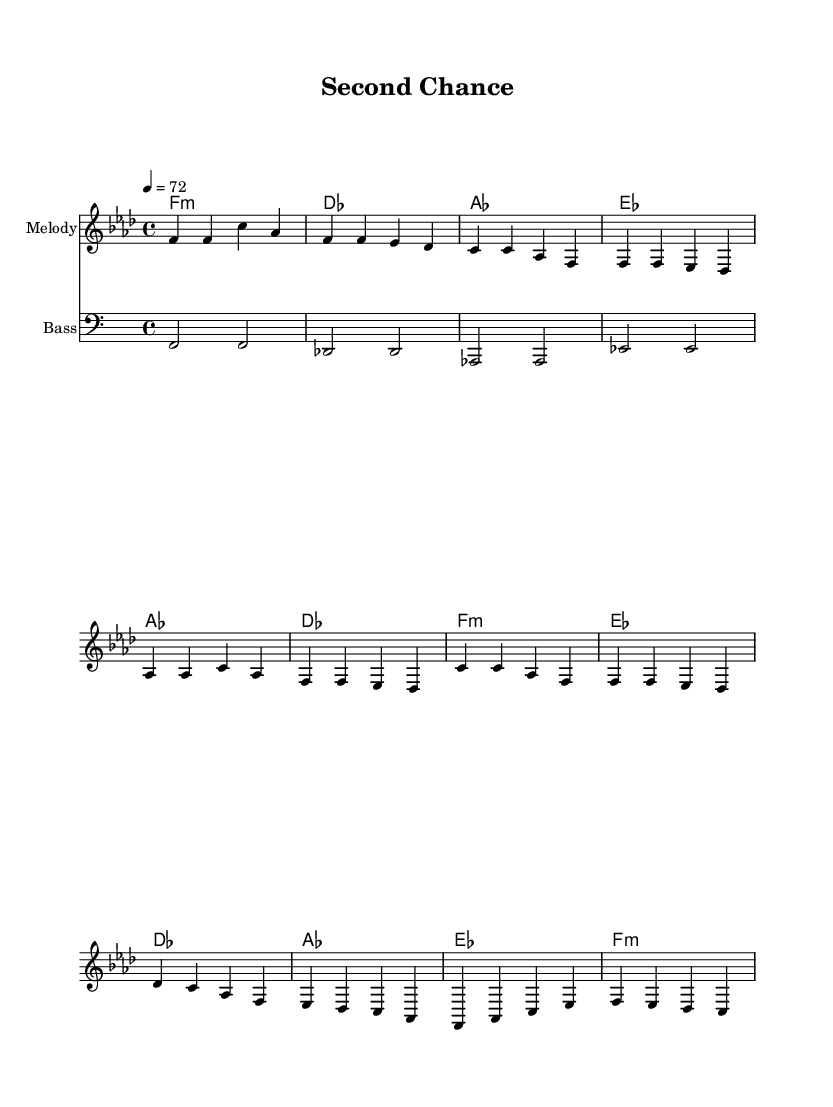What is the key signature of this music? The key signature is F minor, which has four flats (B♭, E♭, A♭, and D♭). This is indicated at the beginning of the sheet music.
Answer: F minor What is the time signature of this music? The time signature is indicated as 4/4, meaning there are four beats in each measure. This is shown at the beginning of the sheet music immediately after the key signature.
Answer: 4/4 What is the tempo marking for this piece? The tempo marking is 4 = 72, which indicates that there are 72 quarter note beats per minute. This reflects the desired speed at which the piece should be played, found at the beginning of the music.
Answer: 72 How many sections are there in the song? There are three main sections: Verse, Chorus, and Bridge, as labeled in the melody lines and structure of the piece. This division helps in understanding the format of the song.
Answer: 3 What is the harmonic progression for the verse? The harmonic progression in the verse uses the chords F minor, Des, A♭, and E♭ for each measure, which is listed in the harmonies section. This specific sequence outlines the chord structure for the verse.
Answer: F minor, Des, A♭, E♭ What is a characteristic element of Rhythm and Blues reflected in this piece? The piece features expressive melodies and emotional lyrics typical of Rhythm and Blues, along with a rich harmonic structure that supports themes of struggle and reintegration. This is common in contemporary R&B ballads.
Answer: Expressive melodies 